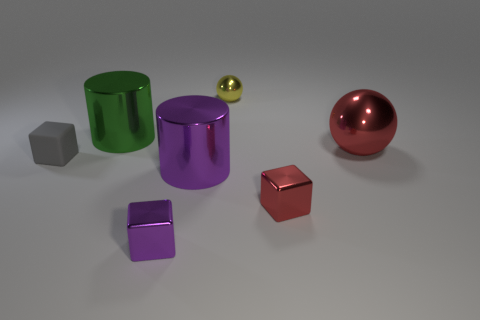Are there any other things that are made of the same material as the gray object?
Offer a terse response. No. What color is the other thing that is the same shape as the big purple object?
Give a very brief answer. Green. There is a red object that is behind the gray cube; how many red shiny spheres are behind it?
Ensure brevity in your answer.  0. How many cubes are either tiny purple metal things or small things?
Your answer should be very brief. 3. Is there a small cyan cube?
Ensure brevity in your answer.  No. There is a yellow metallic object that is the same shape as the large red shiny thing; what is its size?
Your answer should be very brief. Small. There is a red object behind the block that is on the right side of the big purple cylinder; what shape is it?
Offer a terse response. Sphere. How many blue objects are either shiny things or matte balls?
Offer a terse response. 0. The tiny rubber thing has what color?
Offer a terse response. Gray. Is the size of the purple block the same as the red cube?
Your answer should be compact. Yes. 